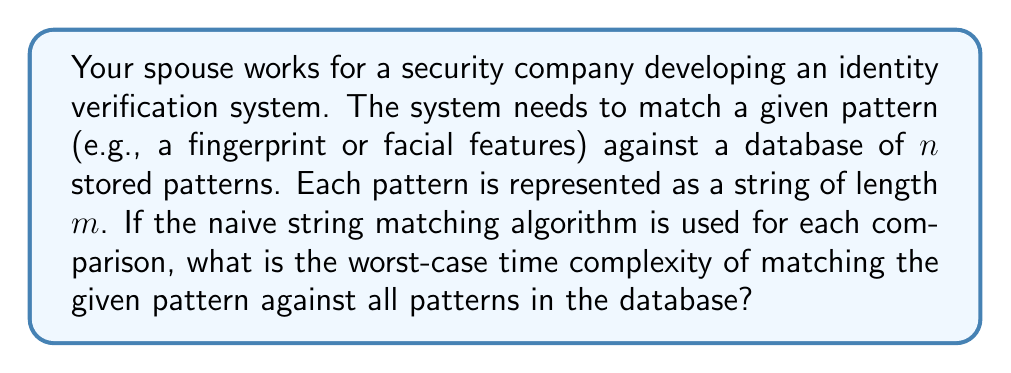What is the answer to this math problem? Let's break this down step-by-step:

1) First, we need to understand the naive string matching algorithm. For a pattern of length $m$ and a text of length $n$, the worst-case time complexity is $O(mn)$.

2) In this case, we're matching a pattern of length $m$ against $n$ different patterns, each also of length $m$.

3) For each of the $n$ patterns in the database:
   - We perform a string matching operation that takes $O(m^2)$ time in the worst case.
   
4) We repeat this process $n$ times, once for each pattern in the database.

5) Therefore, the total time complexity is:

   $$O(n \cdot m^2)$$

6) This can be interpreted as: for each of the $n$ patterns in the database, we're performing an $O(m^2)$ operation.

It's worth noting that while this analysis gives us the correct worst-case time complexity, in practice, more efficient algorithms like KMP or Boyer-Moore are often used for pattern matching in real-world identity verification systems.
Answer: The worst-case time complexity is $O(n \cdot m^2)$, where $n$ is the number of patterns in the database and $m$ is the length of each pattern. 